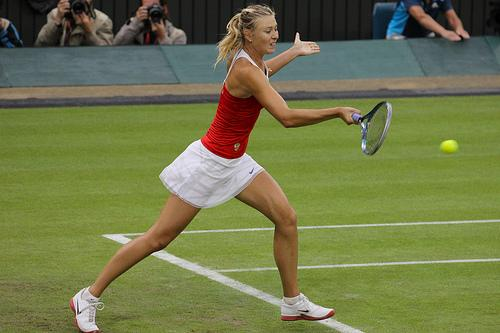What is a unique feature of the woman's hair? The woman's hair is in a ponytail. What color are the white lines on the tennis court painted on? The white lines are painted on the green tennis court. Are there any people holding cameras in the image? If so, how many? Yes, there are at least two men holding cameras and taking photographs. How would you describe the interaction between the tennis ball and the racket in the image? The tennis ball is flying towards the racket as the woman swings it, and the two are about to make contact for a hit. Describe the clothing the woman is wearing. The woman is wearing a red top, white tennis skirt, and red and white tennis shoes. What is the main activity taking place in the image? A woman is playing tennis, swinging her racket to hit a flying tennis ball. What object is the woman holding in her hand? The woman is holding a blue and gray tennis racket. What is one person doing near the fence barrier? One person is leaning on the fence barrier. Identify the color and size of the tennis ball. The tennis ball is small and green in color. What is happening with the tennis ball and the racket in the image? The tennis racket is about to hit the yellow tennis ball, which is flying towards it. Are there three men taking photographs in the image? There are only two men mentioned to be taking photographs, not three. What object is located near the woman playing tennis in the image? A tennis ball What sport is being played in the image? Tennis Can you name any specific features of the tennis court? The tennis court has green ground and white lines Who is about to hit a tennis ball? A woman wearing red and white Which of the following describes the tennis projectile? B. Yellow tennis ball What is a noteworthy attribute of the tennis racket in the photo? It is blue and gray Describe the woman's outfit. The woman is wearing a red top, white tennis skirt, and red and white sneakers What activity is the woman engaged in, and how does it relate to the other objects in the image? The woman is playing tennis, swinging the racket to hit the ball on the green tennis court with white lines List the objects and their colors which are visible within the scene. Tennis ball - green, racket - blue and gray, grass - green, skirt - white, vest - red, camera - unmentioned, shoe - red and white, line - white Can you see the orange and white striped tennis shoes the woman is wearing? The woman is mentioned to be wearing red and white tennis shoes, not orange and white striped. What footwear is the woman wearing while playing tennis? Red and white tennis shoes Is the woman wearing a black skirt? There is no mention of a black skirt in the image. The woman is mentioned to be wearing a white tennis skirt. What are the people in the photo doing? The woman is playing tennis, and two men are taking photographs Does the man in the image have a red and white tank top? There is no mention of a man wearing a red and white tank top in the image. It is a woman who is mentioned to have a red and white tank top. What is the woman's hairstyle in this image? Ponytail Name an object in the image that is not related to the sport being played. Camera What does the hairstyle of the woman in the image indicate? An active lifestyle Which two characters are holding cameras? Two men taking photographs and a person leaning on barrier Is this the tennis ball that is blue in color? There is no mention of a blue tennis ball in the image, only green and yellow tennis balls are mentioned. Is the woman's hair in a bun? The woman's hair is mentioned to be in a ponytail, not a bun. What is the captured event in this image? A woman playing tennis, about to hit the ball What color is the small ball in the image? Green Circle the tennis racket, ball, and white line on the court in the image. Tennis racket: X:338 Y:97, Ball: X:438 Y:137, White line: X:102 Y:220 